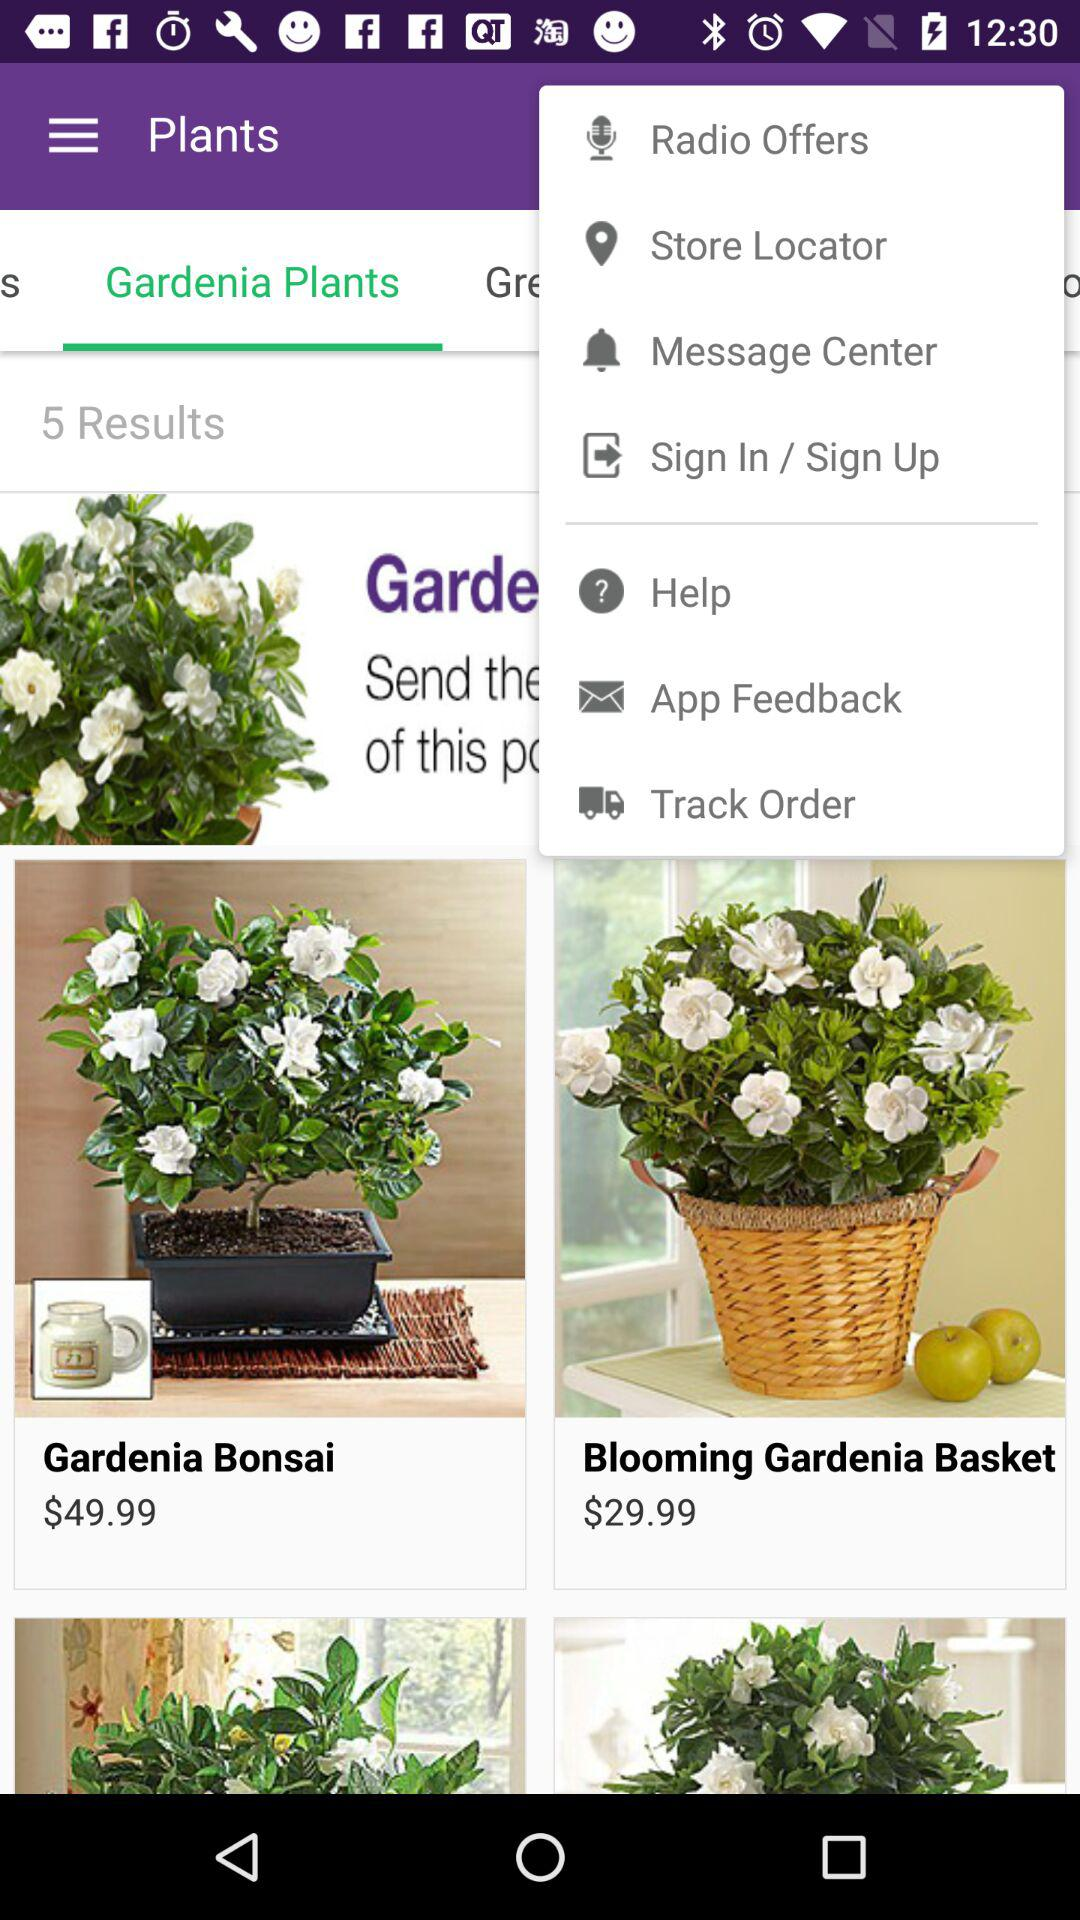Which basket's price is $29.99? $29.99 is the price of "Blooming Gardenia Basket". 